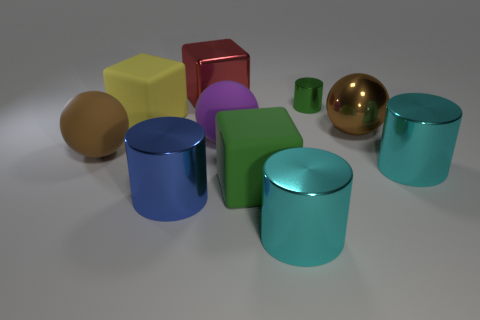Subtract all brown metal spheres. How many spheres are left? 2 Subtract all brown spheres. How many spheres are left? 1 Add 10 green metal blocks. How many green metal blocks exist? 10 Subtract 0 cyan cubes. How many objects are left? 10 Subtract all cylinders. How many objects are left? 6 Subtract 1 cubes. How many cubes are left? 2 Subtract all cyan cubes. Subtract all red balls. How many cubes are left? 3 Subtract all blue balls. How many cyan cylinders are left? 2 Subtract all purple cylinders. Subtract all big red metallic blocks. How many objects are left? 9 Add 9 large purple balls. How many large purple balls are left? 10 